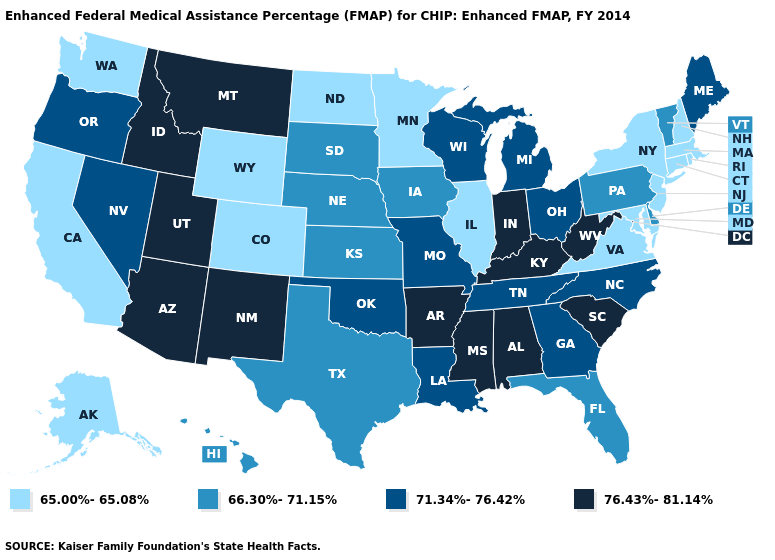Does Wisconsin have the highest value in the USA?
Short answer required. No. What is the value of Maryland?
Concise answer only. 65.00%-65.08%. What is the value of Pennsylvania?
Short answer required. 66.30%-71.15%. What is the value of Michigan?
Give a very brief answer. 71.34%-76.42%. What is the lowest value in states that border Arkansas?
Write a very short answer. 66.30%-71.15%. Name the states that have a value in the range 66.30%-71.15%?
Answer briefly. Delaware, Florida, Hawaii, Iowa, Kansas, Nebraska, Pennsylvania, South Dakota, Texas, Vermont. What is the value of Kansas?
Quick response, please. 66.30%-71.15%. Among the states that border Mississippi , does Louisiana have the lowest value?
Write a very short answer. Yes. Name the states that have a value in the range 71.34%-76.42%?
Short answer required. Georgia, Louisiana, Maine, Michigan, Missouri, Nevada, North Carolina, Ohio, Oklahoma, Oregon, Tennessee, Wisconsin. Which states have the highest value in the USA?
Give a very brief answer. Alabama, Arizona, Arkansas, Idaho, Indiana, Kentucky, Mississippi, Montana, New Mexico, South Carolina, Utah, West Virginia. What is the value of Vermont?
Keep it brief. 66.30%-71.15%. Among the states that border Kentucky , which have the lowest value?
Quick response, please. Illinois, Virginia. Which states have the lowest value in the South?
Give a very brief answer. Maryland, Virginia. What is the lowest value in the USA?
Short answer required. 65.00%-65.08%. 